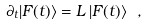Convert formula to latex. <formula><loc_0><loc_0><loc_500><loc_500>\partial _ { t } | F ( t ) \rangle = L \, | F ( t ) \rangle \ ,</formula> 